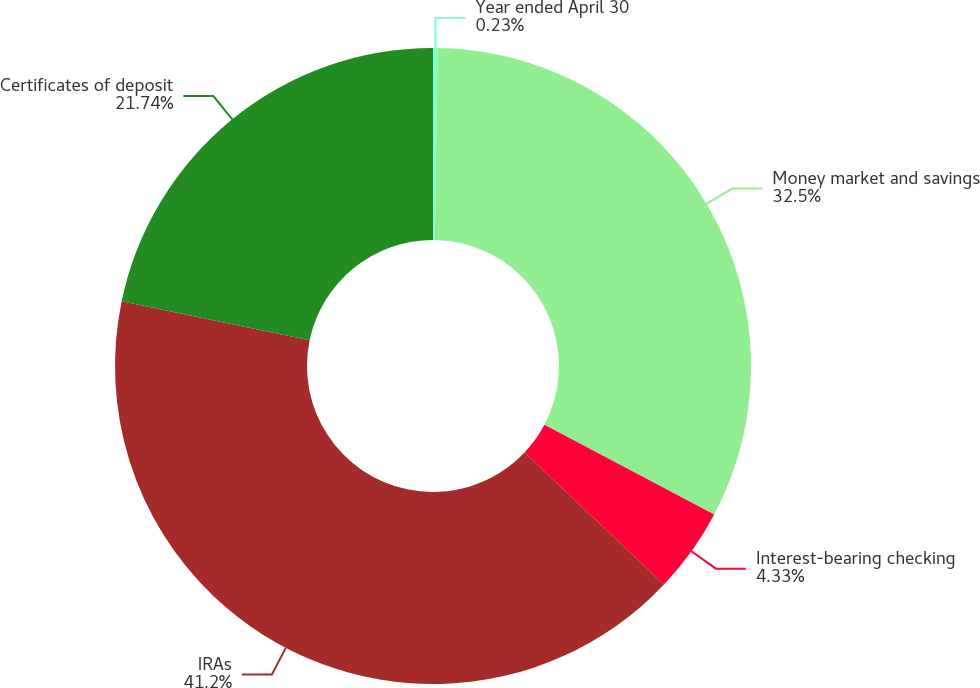Convert chart to OTSL. <chart><loc_0><loc_0><loc_500><loc_500><pie_chart><fcel>Year ended April 30<fcel>Money market and savings<fcel>Interest-bearing checking<fcel>IRAs<fcel>Certificates of deposit<nl><fcel>0.23%<fcel>32.5%<fcel>4.33%<fcel>41.2%<fcel>21.74%<nl></chart> 